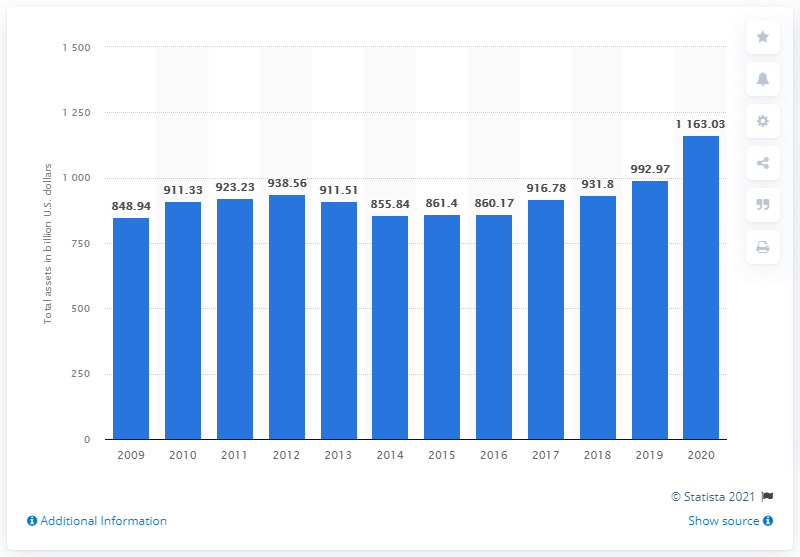Draw attention to some important aspects in this diagram. In 2020, the total assets of Goldman Sachs were approximately 1,163.03 dollars. 